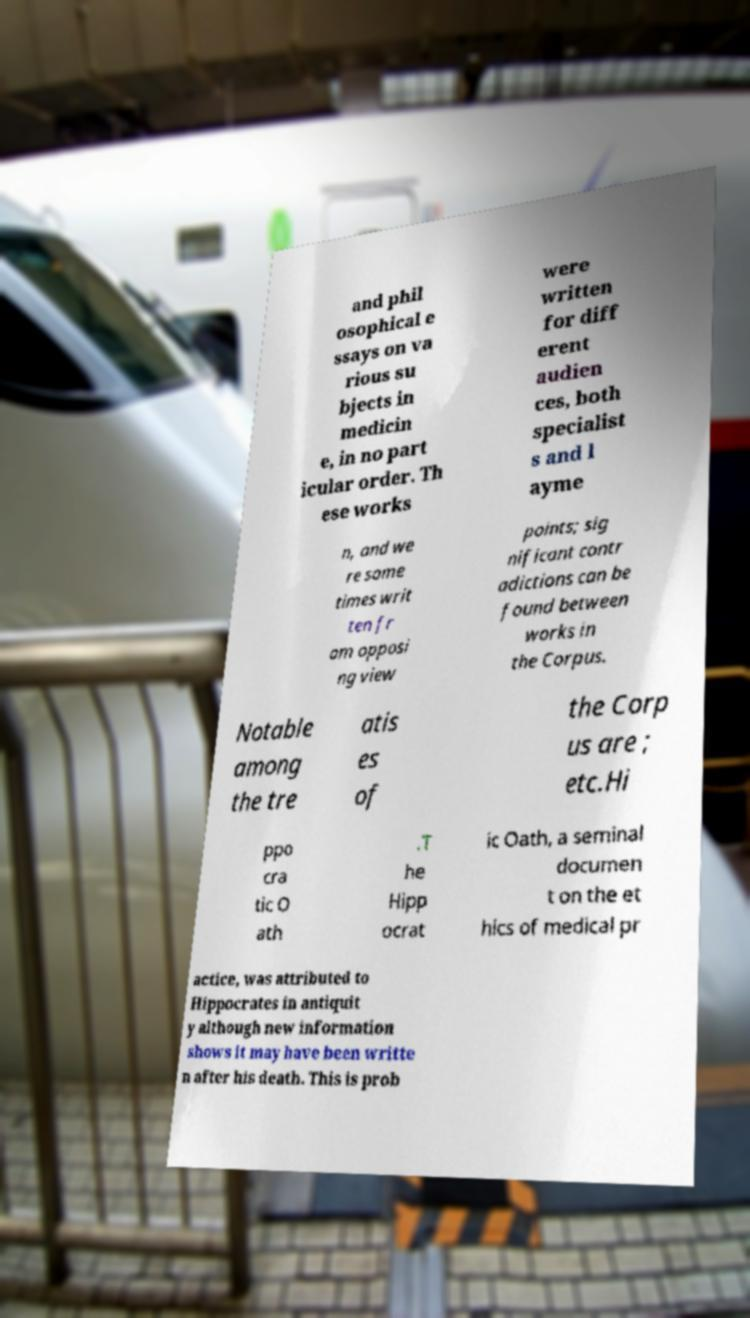Can you read and provide the text displayed in the image?This photo seems to have some interesting text. Can you extract and type it out for me? and phil osophical e ssays on va rious su bjects in medicin e, in no part icular order. Th ese works were written for diff erent audien ces, both specialist s and l ayme n, and we re some times writ ten fr om opposi ng view points; sig nificant contr adictions can be found between works in the Corpus. Notable among the tre atis es of the Corp us are ; etc.Hi ppo cra tic O ath .T he Hipp ocrat ic Oath, a seminal documen t on the et hics of medical pr actice, was attributed to Hippocrates in antiquit y although new information shows it may have been writte n after his death. This is prob 